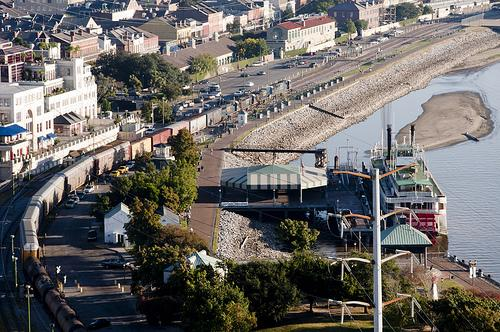Mention the main aspects of the natural environment and man-made structures in the image. There is a large body of calm blue water, lush trees, and dirt island in the natural environment, and buildings with red roofs, train tracks, and tall electricity poles as man-made structures. Point out two objects in the image that depict motion or activity. The train moving on the tracks with many compartments, and the person walking on the sidewalk. Describe the color schemes of three objects or locations in the image. The building is white with a red roof, the large body of water is calm and blue, and the trees have rich green leaves. Mention two objects and their locations that could be part of a transportation theme. A train with many compartments is on the track near the white building, and cars are parked on the street near the same building. Identify the place where a person is walking and mention the locations of two parked vehicles. A person is walking on the sidewalk, while two yellow taxis are parked on the street and some cars are parked in the empty parking lot. Explain the time and setting of the photo based on visual information. The photo was taken outdoors during daytime, with sunlight casting shadows on trees and buildings, and a bright clear sky over the city. Imagine being a travel writer and describe this location in a picturesque manner. Nestled alongside a pristine lake with calm blue waters, this charming town is a hidden gem. Tall, lush trees provide shade and cast dancing shadows on the ground, while quaint red-roofed buildings create a welcoming atmosphere.  Design an advertisement for a travel agency using visual elements from the image. "Discover the beauty of lakeside living! Experience lush green surroundings, serene waters, and charming buildings with red roofed houses. Relax and unwind with a scenic train ride through the quaint city. Book your getaway now!" List three prominent objects in the image along with their distinguishing features. A large body of clear, calm blue water; trees with lush green leaves, casting shadows; white building with many windows and red roof. Tell a short narrative involving the train, road, and the nearby building. On a sunny day, a long train with many compartments was moving along the tracks, passing by a large white building with a red roof. Nearby, cars were parked on the curved street, and people walked on the sidewalk. 